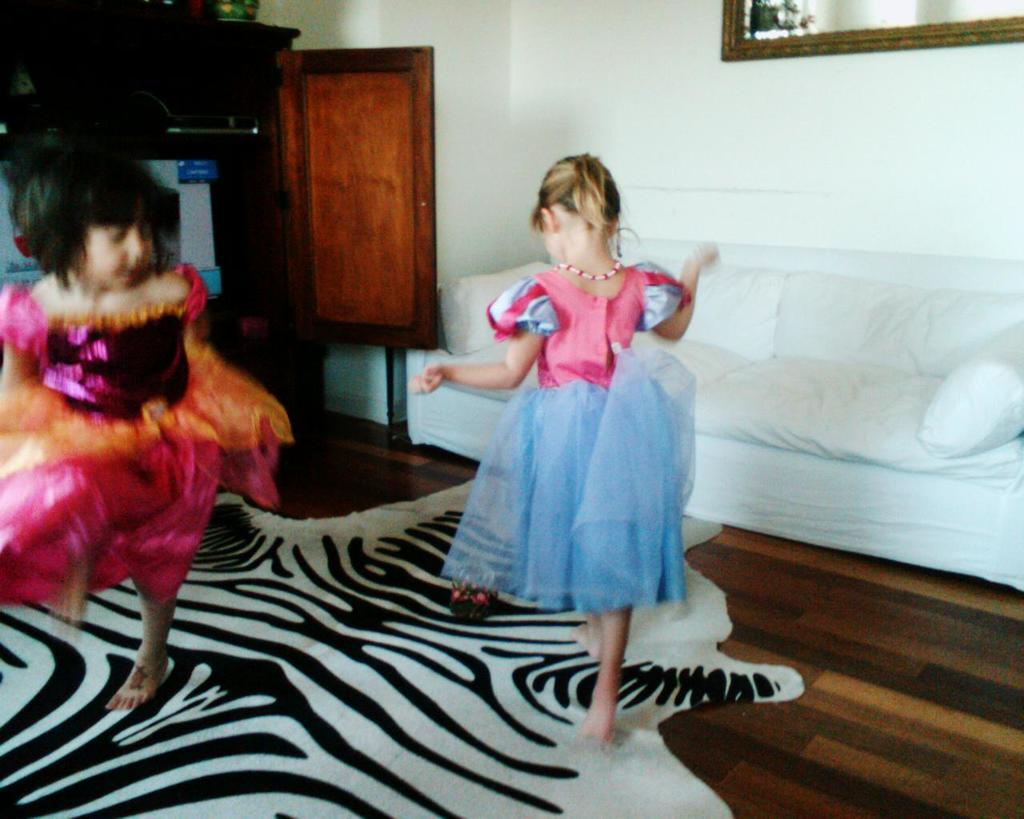How many girls are in the image? There are two girls in the image. What are the girls doing in the image? The girls are dancing on the floor. What can be seen in the background of the image? There is a white color sofa and a frame attached to the wall in the background of the image. What type of door is visible in the image? A wooden door is visible in the image. What type of pocket can be seen on the girls' clothes in the image? There is no pocket visible on the girls' clothes in the image. What type of net is used to catch the songs in the image? There is no net or mention of songs in the image; it features two girls dancing on the floor. 